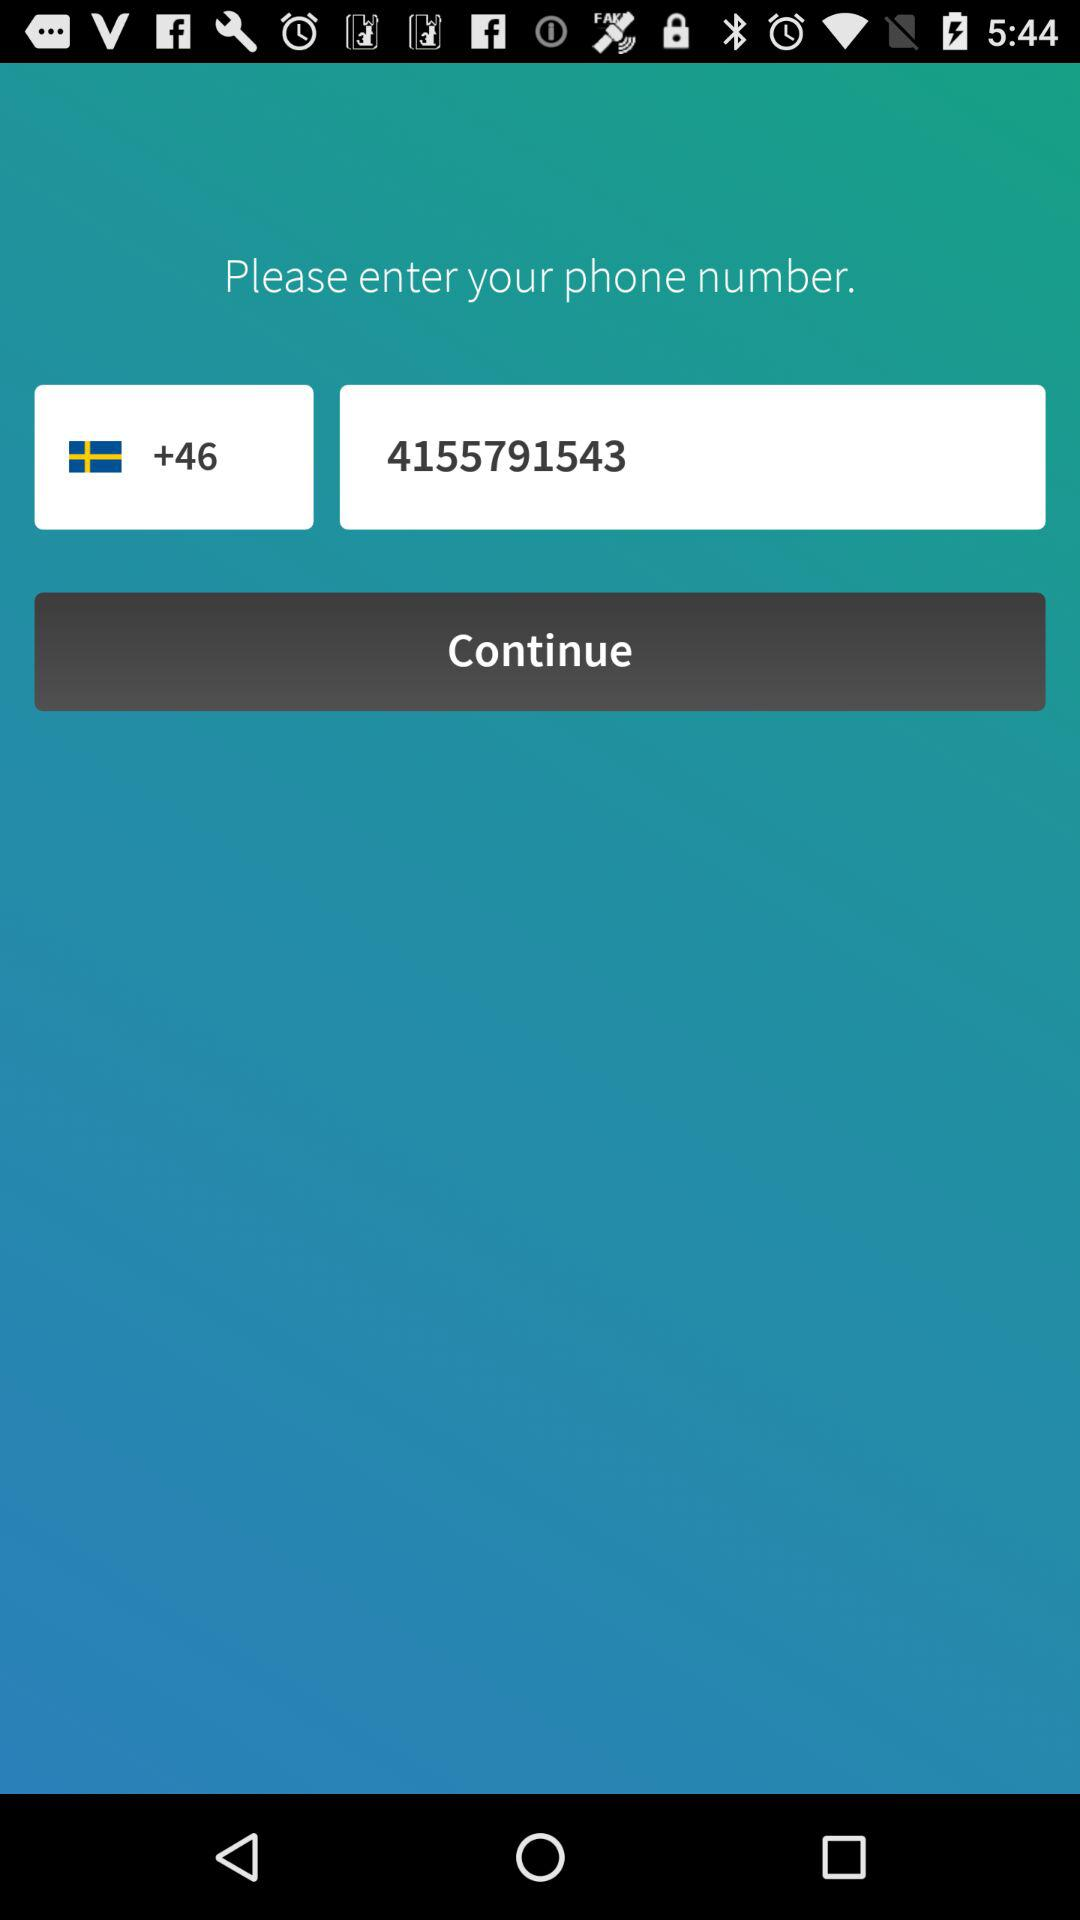What is the phone number? The phone number is +46 4155791543. 